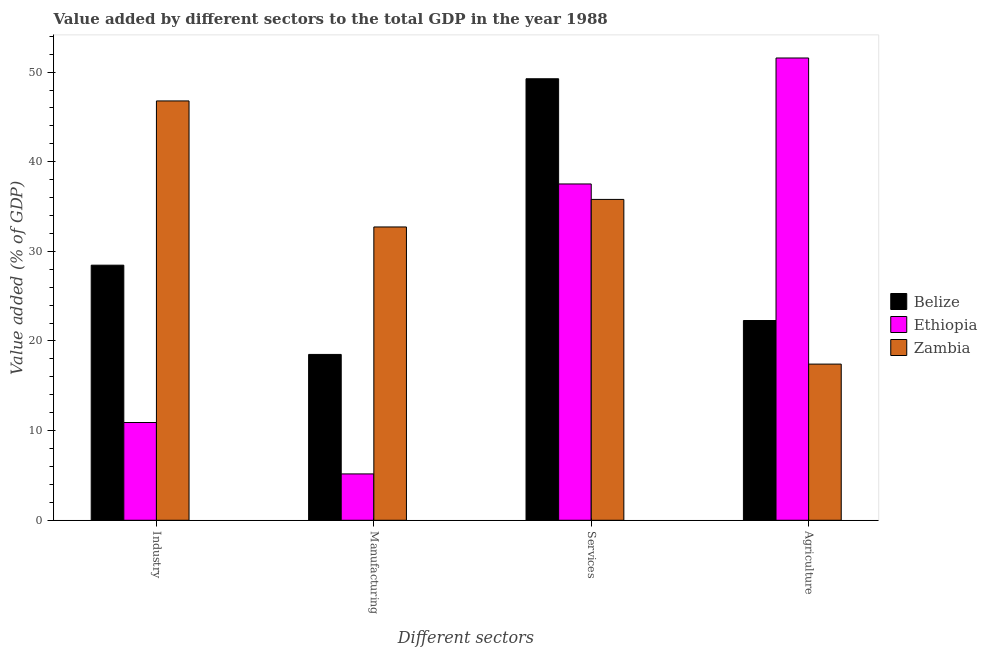How many different coloured bars are there?
Your answer should be very brief. 3. How many groups of bars are there?
Provide a succinct answer. 4. Are the number of bars on each tick of the X-axis equal?
Offer a terse response. Yes. How many bars are there on the 1st tick from the right?
Your response must be concise. 3. What is the label of the 4th group of bars from the left?
Ensure brevity in your answer.  Agriculture. What is the value added by manufacturing sector in Ethiopia?
Offer a very short reply. 5.17. Across all countries, what is the maximum value added by services sector?
Provide a short and direct response. 49.26. Across all countries, what is the minimum value added by services sector?
Provide a short and direct response. 35.8. In which country was the value added by services sector maximum?
Your answer should be very brief. Belize. In which country was the value added by services sector minimum?
Provide a succinct answer. Zambia. What is the total value added by agricultural sector in the graph?
Provide a short and direct response. 91.28. What is the difference between the value added by industrial sector in Belize and that in Ethiopia?
Ensure brevity in your answer.  17.55. What is the difference between the value added by manufacturing sector in Belize and the value added by agricultural sector in Zambia?
Provide a succinct answer. 1.08. What is the average value added by agricultural sector per country?
Your answer should be compact. 30.43. What is the difference between the value added by industrial sector and value added by agricultural sector in Belize?
Your answer should be compact. 6.17. What is the ratio of the value added by agricultural sector in Ethiopia to that in Zambia?
Your response must be concise. 2.96. Is the difference between the value added by agricultural sector in Zambia and Belize greater than the difference between the value added by manufacturing sector in Zambia and Belize?
Your response must be concise. No. What is the difference between the highest and the second highest value added by manufacturing sector?
Offer a very short reply. 14.22. What is the difference between the highest and the lowest value added by manufacturing sector?
Offer a terse response. 27.55. In how many countries, is the value added by manufacturing sector greater than the average value added by manufacturing sector taken over all countries?
Keep it short and to the point. 1. Is the sum of the value added by services sector in Zambia and Belize greater than the maximum value added by agricultural sector across all countries?
Provide a short and direct response. Yes. Is it the case that in every country, the sum of the value added by industrial sector and value added by manufacturing sector is greater than the sum of value added by agricultural sector and value added by services sector?
Your answer should be compact. No. What does the 1st bar from the left in Manufacturing represents?
Keep it short and to the point. Belize. What does the 1st bar from the right in Industry represents?
Offer a very short reply. Zambia. Is it the case that in every country, the sum of the value added by industrial sector and value added by manufacturing sector is greater than the value added by services sector?
Offer a terse response. No. What is the difference between two consecutive major ticks on the Y-axis?
Provide a succinct answer. 10. Are the values on the major ticks of Y-axis written in scientific E-notation?
Offer a very short reply. No. Does the graph contain any zero values?
Your answer should be very brief. No. How are the legend labels stacked?
Your answer should be compact. Vertical. What is the title of the graph?
Offer a terse response. Value added by different sectors to the total GDP in the year 1988. What is the label or title of the X-axis?
Your answer should be very brief. Different sectors. What is the label or title of the Y-axis?
Your response must be concise. Value added (% of GDP). What is the Value added (% of GDP) in Belize in Industry?
Keep it short and to the point. 28.46. What is the Value added (% of GDP) of Ethiopia in Industry?
Your answer should be very brief. 10.91. What is the Value added (% of GDP) of Zambia in Industry?
Your response must be concise. 46.78. What is the Value added (% of GDP) in Belize in Manufacturing?
Ensure brevity in your answer.  18.5. What is the Value added (% of GDP) of Ethiopia in Manufacturing?
Make the answer very short. 5.17. What is the Value added (% of GDP) in Zambia in Manufacturing?
Ensure brevity in your answer.  32.72. What is the Value added (% of GDP) of Belize in Services?
Offer a very short reply. 49.26. What is the Value added (% of GDP) in Ethiopia in Services?
Ensure brevity in your answer.  37.52. What is the Value added (% of GDP) in Zambia in Services?
Make the answer very short. 35.8. What is the Value added (% of GDP) in Belize in Agriculture?
Offer a very short reply. 22.28. What is the Value added (% of GDP) of Ethiopia in Agriculture?
Keep it short and to the point. 51.57. What is the Value added (% of GDP) of Zambia in Agriculture?
Keep it short and to the point. 17.42. Across all Different sectors, what is the maximum Value added (% of GDP) in Belize?
Your answer should be very brief. 49.26. Across all Different sectors, what is the maximum Value added (% of GDP) of Ethiopia?
Make the answer very short. 51.57. Across all Different sectors, what is the maximum Value added (% of GDP) of Zambia?
Offer a very short reply. 46.78. Across all Different sectors, what is the minimum Value added (% of GDP) in Belize?
Give a very brief answer. 18.5. Across all Different sectors, what is the minimum Value added (% of GDP) in Ethiopia?
Offer a terse response. 5.17. Across all Different sectors, what is the minimum Value added (% of GDP) in Zambia?
Give a very brief answer. 17.42. What is the total Value added (% of GDP) in Belize in the graph?
Your response must be concise. 118.5. What is the total Value added (% of GDP) of Ethiopia in the graph?
Keep it short and to the point. 105.17. What is the total Value added (% of GDP) of Zambia in the graph?
Provide a succinct answer. 132.72. What is the difference between the Value added (% of GDP) of Belize in Industry and that in Manufacturing?
Your response must be concise. 9.96. What is the difference between the Value added (% of GDP) in Ethiopia in Industry and that in Manufacturing?
Your answer should be compact. 5.74. What is the difference between the Value added (% of GDP) of Zambia in Industry and that in Manufacturing?
Your answer should be compact. 14.06. What is the difference between the Value added (% of GDP) of Belize in Industry and that in Services?
Ensure brevity in your answer.  -20.8. What is the difference between the Value added (% of GDP) of Ethiopia in Industry and that in Services?
Make the answer very short. -26.61. What is the difference between the Value added (% of GDP) of Zambia in Industry and that in Services?
Give a very brief answer. 10.99. What is the difference between the Value added (% of GDP) of Belize in Industry and that in Agriculture?
Offer a very short reply. 6.17. What is the difference between the Value added (% of GDP) of Ethiopia in Industry and that in Agriculture?
Provide a succinct answer. -40.67. What is the difference between the Value added (% of GDP) in Zambia in Industry and that in Agriculture?
Provide a short and direct response. 29.36. What is the difference between the Value added (% of GDP) in Belize in Manufacturing and that in Services?
Keep it short and to the point. -30.75. What is the difference between the Value added (% of GDP) in Ethiopia in Manufacturing and that in Services?
Give a very brief answer. -32.35. What is the difference between the Value added (% of GDP) of Zambia in Manufacturing and that in Services?
Offer a terse response. -3.07. What is the difference between the Value added (% of GDP) in Belize in Manufacturing and that in Agriculture?
Offer a very short reply. -3.78. What is the difference between the Value added (% of GDP) of Ethiopia in Manufacturing and that in Agriculture?
Your answer should be very brief. -46.4. What is the difference between the Value added (% of GDP) of Zambia in Manufacturing and that in Agriculture?
Your answer should be compact. 15.3. What is the difference between the Value added (% of GDP) of Belize in Services and that in Agriculture?
Provide a succinct answer. 26.97. What is the difference between the Value added (% of GDP) of Ethiopia in Services and that in Agriculture?
Offer a very short reply. -14.05. What is the difference between the Value added (% of GDP) in Zambia in Services and that in Agriculture?
Provide a short and direct response. 18.37. What is the difference between the Value added (% of GDP) in Belize in Industry and the Value added (% of GDP) in Ethiopia in Manufacturing?
Ensure brevity in your answer.  23.29. What is the difference between the Value added (% of GDP) in Belize in Industry and the Value added (% of GDP) in Zambia in Manufacturing?
Offer a very short reply. -4.26. What is the difference between the Value added (% of GDP) of Ethiopia in Industry and the Value added (% of GDP) of Zambia in Manufacturing?
Provide a succinct answer. -21.82. What is the difference between the Value added (% of GDP) of Belize in Industry and the Value added (% of GDP) of Ethiopia in Services?
Offer a terse response. -9.06. What is the difference between the Value added (% of GDP) in Belize in Industry and the Value added (% of GDP) in Zambia in Services?
Provide a short and direct response. -7.34. What is the difference between the Value added (% of GDP) of Ethiopia in Industry and the Value added (% of GDP) of Zambia in Services?
Provide a succinct answer. -24.89. What is the difference between the Value added (% of GDP) in Belize in Industry and the Value added (% of GDP) in Ethiopia in Agriculture?
Make the answer very short. -23.11. What is the difference between the Value added (% of GDP) in Belize in Industry and the Value added (% of GDP) in Zambia in Agriculture?
Your answer should be compact. 11.04. What is the difference between the Value added (% of GDP) in Ethiopia in Industry and the Value added (% of GDP) in Zambia in Agriculture?
Your answer should be compact. -6.52. What is the difference between the Value added (% of GDP) of Belize in Manufacturing and the Value added (% of GDP) of Ethiopia in Services?
Your answer should be compact. -19.02. What is the difference between the Value added (% of GDP) in Belize in Manufacturing and the Value added (% of GDP) in Zambia in Services?
Provide a succinct answer. -17.29. What is the difference between the Value added (% of GDP) of Ethiopia in Manufacturing and the Value added (% of GDP) of Zambia in Services?
Make the answer very short. -30.62. What is the difference between the Value added (% of GDP) in Belize in Manufacturing and the Value added (% of GDP) in Ethiopia in Agriculture?
Offer a terse response. -33.07. What is the difference between the Value added (% of GDP) of Belize in Manufacturing and the Value added (% of GDP) of Zambia in Agriculture?
Keep it short and to the point. 1.08. What is the difference between the Value added (% of GDP) in Ethiopia in Manufacturing and the Value added (% of GDP) in Zambia in Agriculture?
Make the answer very short. -12.25. What is the difference between the Value added (% of GDP) of Belize in Services and the Value added (% of GDP) of Ethiopia in Agriculture?
Offer a terse response. -2.32. What is the difference between the Value added (% of GDP) of Belize in Services and the Value added (% of GDP) of Zambia in Agriculture?
Make the answer very short. 31.83. What is the difference between the Value added (% of GDP) of Ethiopia in Services and the Value added (% of GDP) of Zambia in Agriculture?
Offer a very short reply. 20.1. What is the average Value added (% of GDP) in Belize per Different sectors?
Your answer should be very brief. 29.63. What is the average Value added (% of GDP) of Ethiopia per Different sectors?
Your answer should be compact. 26.29. What is the average Value added (% of GDP) of Zambia per Different sectors?
Your answer should be very brief. 33.18. What is the difference between the Value added (% of GDP) in Belize and Value added (% of GDP) in Ethiopia in Industry?
Ensure brevity in your answer.  17.55. What is the difference between the Value added (% of GDP) in Belize and Value added (% of GDP) in Zambia in Industry?
Give a very brief answer. -18.32. What is the difference between the Value added (% of GDP) in Ethiopia and Value added (% of GDP) in Zambia in Industry?
Your answer should be very brief. -35.88. What is the difference between the Value added (% of GDP) of Belize and Value added (% of GDP) of Ethiopia in Manufacturing?
Your response must be concise. 13.33. What is the difference between the Value added (% of GDP) of Belize and Value added (% of GDP) of Zambia in Manufacturing?
Offer a very short reply. -14.22. What is the difference between the Value added (% of GDP) in Ethiopia and Value added (% of GDP) in Zambia in Manufacturing?
Give a very brief answer. -27.55. What is the difference between the Value added (% of GDP) in Belize and Value added (% of GDP) in Ethiopia in Services?
Make the answer very short. 11.74. What is the difference between the Value added (% of GDP) in Belize and Value added (% of GDP) in Zambia in Services?
Offer a terse response. 13.46. What is the difference between the Value added (% of GDP) of Ethiopia and Value added (% of GDP) of Zambia in Services?
Make the answer very short. 1.72. What is the difference between the Value added (% of GDP) of Belize and Value added (% of GDP) of Ethiopia in Agriculture?
Offer a terse response. -29.29. What is the difference between the Value added (% of GDP) in Belize and Value added (% of GDP) in Zambia in Agriculture?
Your answer should be very brief. 4.86. What is the difference between the Value added (% of GDP) of Ethiopia and Value added (% of GDP) of Zambia in Agriculture?
Keep it short and to the point. 34.15. What is the ratio of the Value added (% of GDP) in Belize in Industry to that in Manufacturing?
Your answer should be compact. 1.54. What is the ratio of the Value added (% of GDP) in Ethiopia in Industry to that in Manufacturing?
Your answer should be compact. 2.11. What is the ratio of the Value added (% of GDP) of Zambia in Industry to that in Manufacturing?
Provide a succinct answer. 1.43. What is the ratio of the Value added (% of GDP) in Belize in Industry to that in Services?
Make the answer very short. 0.58. What is the ratio of the Value added (% of GDP) of Ethiopia in Industry to that in Services?
Offer a very short reply. 0.29. What is the ratio of the Value added (% of GDP) in Zambia in Industry to that in Services?
Provide a succinct answer. 1.31. What is the ratio of the Value added (% of GDP) in Belize in Industry to that in Agriculture?
Keep it short and to the point. 1.28. What is the ratio of the Value added (% of GDP) of Ethiopia in Industry to that in Agriculture?
Offer a terse response. 0.21. What is the ratio of the Value added (% of GDP) of Zambia in Industry to that in Agriculture?
Provide a succinct answer. 2.69. What is the ratio of the Value added (% of GDP) of Belize in Manufacturing to that in Services?
Provide a short and direct response. 0.38. What is the ratio of the Value added (% of GDP) of Ethiopia in Manufacturing to that in Services?
Make the answer very short. 0.14. What is the ratio of the Value added (% of GDP) of Zambia in Manufacturing to that in Services?
Offer a very short reply. 0.91. What is the ratio of the Value added (% of GDP) in Belize in Manufacturing to that in Agriculture?
Offer a very short reply. 0.83. What is the ratio of the Value added (% of GDP) in Ethiopia in Manufacturing to that in Agriculture?
Make the answer very short. 0.1. What is the ratio of the Value added (% of GDP) of Zambia in Manufacturing to that in Agriculture?
Offer a very short reply. 1.88. What is the ratio of the Value added (% of GDP) in Belize in Services to that in Agriculture?
Offer a terse response. 2.21. What is the ratio of the Value added (% of GDP) in Ethiopia in Services to that in Agriculture?
Offer a very short reply. 0.73. What is the ratio of the Value added (% of GDP) of Zambia in Services to that in Agriculture?
Your answer should be very brief. 2.05. What is the difference between the highest and the second highest Value added (% of GDP) in Belize?
Provide a short and direct response. 20.8. What is the difference between the highest and the second highest Value added (% of GDP) in Ethiopia?
Ensure brevity in your answer.  14.05. What is the difference between the highest and the second highest Value added (% of GDP) of Zambia?
Your answer should be compact. 10.99. What is the difference between the highest and the lowest Value added (% of GDP) in Belize?
Your answer should be compact. 30.75. What is the difference between the highest and the lowest Value added (% of GDP) in Ethiopia?
Ensure brevity in your answer.  46.4. What is the difference between the highest and the lowest Value added (% of GDP) of Zambia?
Your answer should be compact. 29.36. 